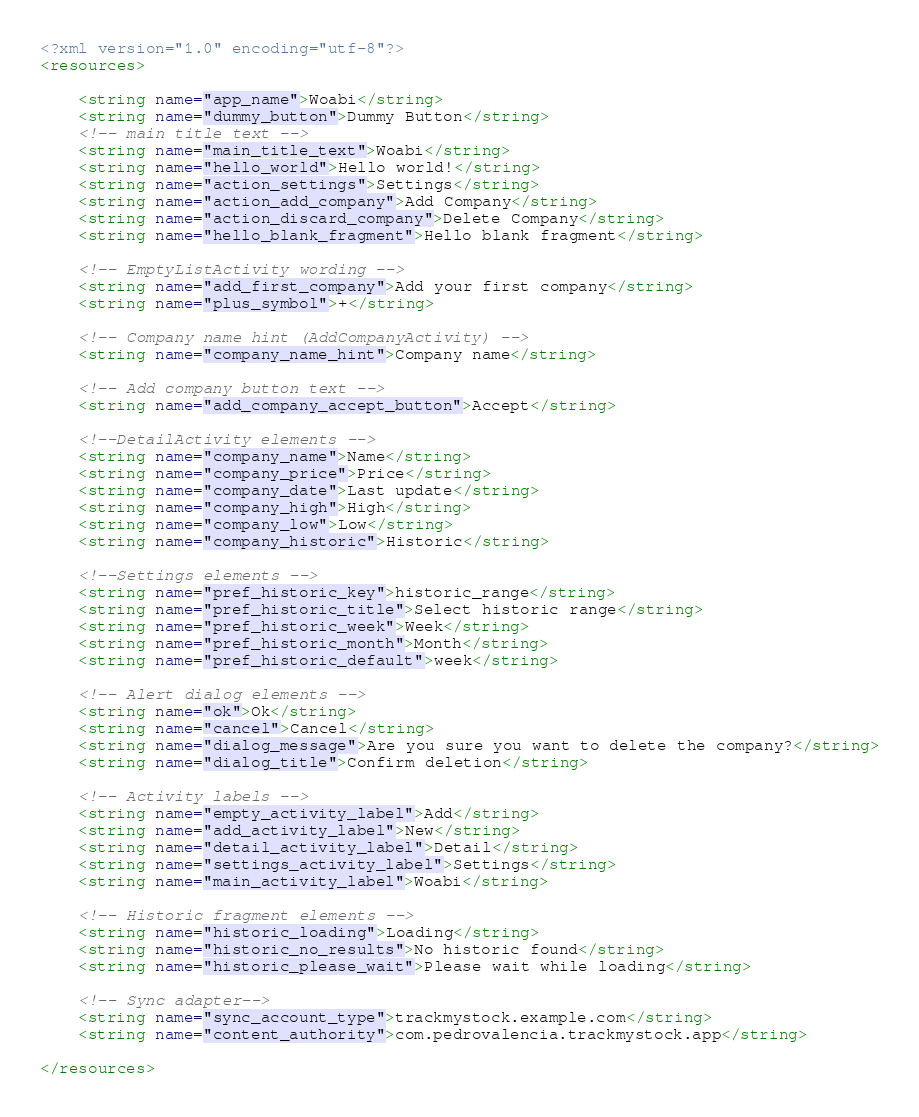Convert code to text. <code><loc_0><loc_0><loc_500><loc_500><_XML_><?xml version="1.0" encoding="utf-8"?>
<resources>

    <string name="app_name">Woabi</string>
    <string name="dummy_button">Dummy Button</string>
    <!-- main title text -->
    <string name="main_title_text">Woabi</string>
    <string name="hello_world">Hello world!</string>
    <string name="action_settings">Settings</string>
    <string name="action_add_company">Add Company</string>
    <string name="action_discard_company">Delete Company</string>
    <string name="hello_blank_fragment">Hello blank fragment</string>

    <!-- EmptyListActivity wording -->
    <string name="add_first_company">Add your first company</string>
    <string name="plus_symbol">+</string>

    <!-- Company name hint (AddCompanyActivity) -->
    <string name="company_name_hint">Company name</string>

    <!-- Add company button text -->
    <string name="add_company_accept_button">Accept</string>

    <!--DetailActivity elements -->
    <string name="company_name">Name</string>
    <string name="company_price">Price</string>
    <string name="company_date">Last update</string>
    <string name="company_high">High</string>
    <string name="company_low">Low</string>
    <string name="company_historic">Historic</string>

    <!--Settings elements -->
    <string name="pref_historic_key">historic_range</string>
    <string name="pref_historic_title">Select historic range</string>
    <string name="pref_historic_week">Week</string>
    <string name="pref_historic_month">Month</string>
    <string name="pref_historic_default">week</string>

    <!-- Alert dialog elements -->
    <string name="ok">Ok</string>
    <string name="cancel">Cancel</string>
    <string name="dialog_message">Are you sure you want to delete the company?</string>
    <string name="dialog_title">Confirm deletion</string>

    <!-- Activity labels -->
    <string name="empty_activity_label">Add</string>
    <string name="add_activity_label">New</string>
    <string name="detail_activity_label">Detail</string>
    <string name="settings_activity_label">Settings</string>
    <string name="main_activity_label">Woabi</string>

    <!-- Historic fragment elements -->
    <string name="historic_loading">Loading</string>
    <string name="historic_no_results">No historic found</string>
    <string name="historic_please_wait">Please wait while loading</string>

    <!-- Sync adapter-->
    <string name="sync_account_type">trackmystock.example.com</string>
    <string name="content_authority">com.pedrovalencia.trackmystock.app</string>

</resources>
</code> 